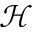Convert formula to latex. <formula><loc_0><loc_0><loc_500><loc_500>\mathcal { H }</formula> 